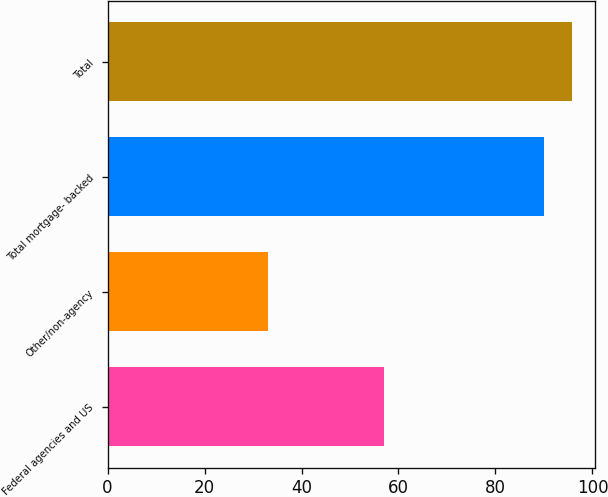<chart> <loc_0><loc_0><loc_500><loc_500><bar_chart><fcel>Federal agencies and US<fcel>Other/non-agency<fcel>Total mortgage- backed<fcel>Total<nl><fcel>57<fcel>33<fcel>90<fcel>95.7<nl></chart> 